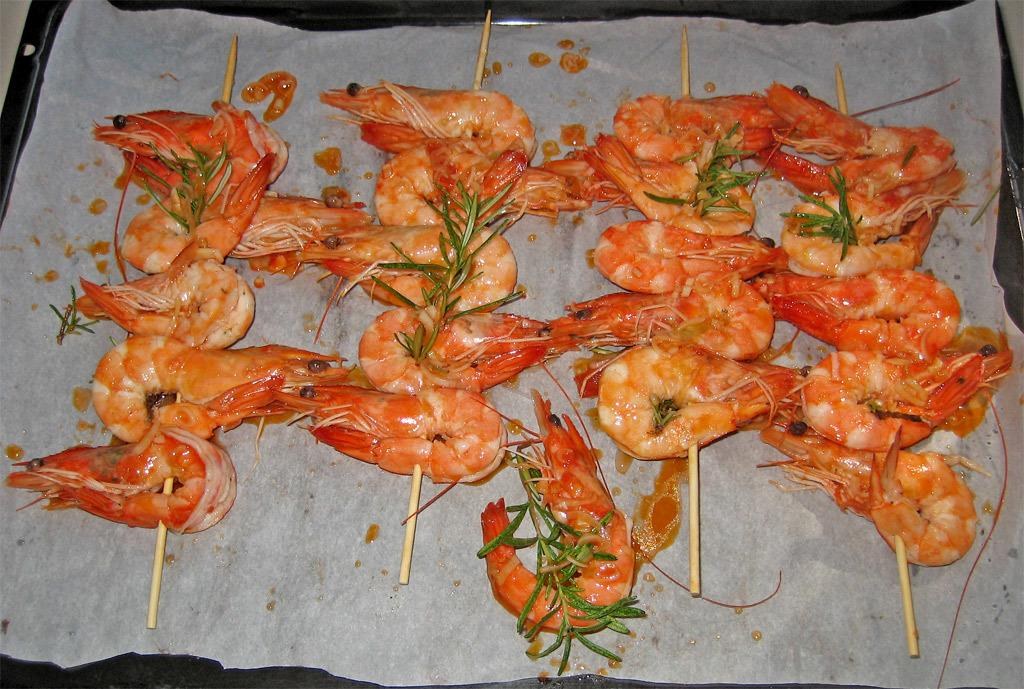What is on the tray that is visible in the image? There is a tray with food in the image. What other item can be seen in the image besides the tray with food? There is a paper in the image. What type of police equipment can be seen in the image? There is no police equipment present in the image. What is the hose used for in the image? There is no hose present in the image. 